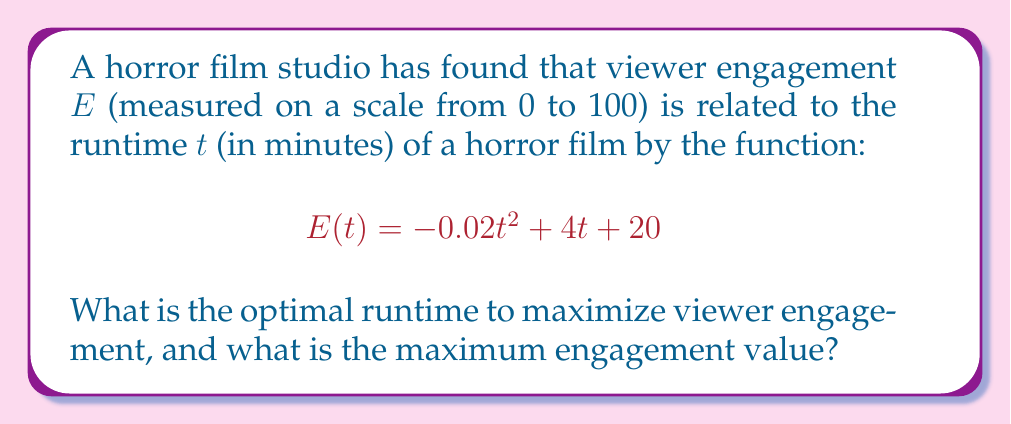Solve this math problem. To find the optimal runtime and maximum engagement, we need to follow these steps:

1) The function $E(t)$ is a quadratic function, and its graph is a parabola. The maximum point of a parabola occurs at its vertex.

2) For a quadratic function in the form $f(x) = ax^2 + bx + c$, the x-coordinate of the vertex is given by $x = -\frac{b}{2a}$.

3) In our case, $a = -0.02$, $b = 4$, and $c = 20$. Let's substitute these values:

   $t = -\frac{4}{2(-0.02)} = -\frac{4}{-0.04} = 100$

4) This means the optimal runtime is 100 minutes.

5) To find the maximum engagement value, we substitute $t = 100$ into the original function:

   $E(100) = -0.02(100)^2 + 4(100) + 20$
           $= -200 + 400 + 20$
           $= 220$

6) However, since engagement is measured on a scale from 0 to 100, we need to cap this value at 100.

Therefore, the optimal runtime is 100 minutes, and the maximum engagement value is 100.
Answer: 100 minutes; 100 